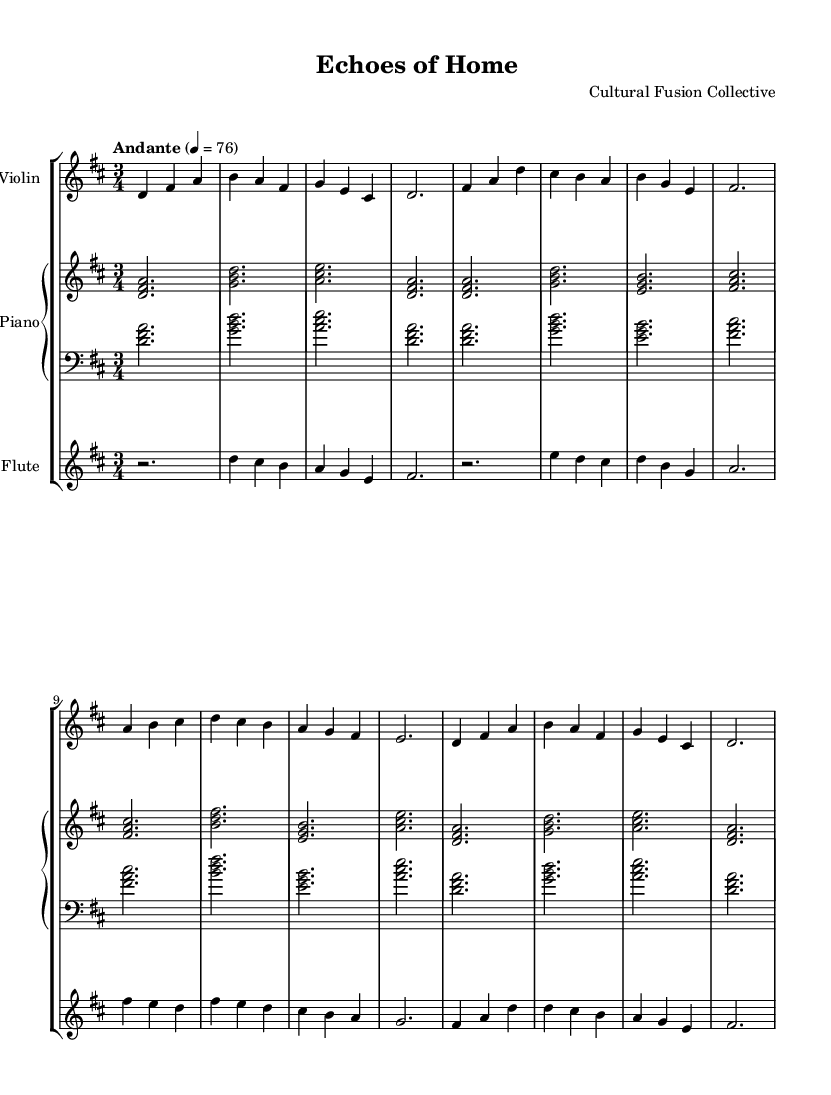What is the key signature of this music? The key signature is indicated at the beginning of the staff, showing two sharps, which indicates D major.
Answer: D major What is the time signature of the piece? The time signature is found as a fraction at the beginning of the sheet music, indicating that there are three beats in each measure, thus 3/4.
Answer: 3/4 What is the tempo marking for this music? The tempo marking "Andante" is stated at the beginning, specifying a moderate pace, and the metronome marking is provided as quarter note equals 76.
Answer: Andante How many measures are there in the violin part? Counting the number of measure bars in the violin part, there are a total of eight measures in the provided section of the music.
Answer: Eight Which instruments are featured in this score? The score includes three instruments, as indicated in the staff group header: Violin, Piano, and Flute.
Answer: Violin, Piano, Flute What is the harmonic structure of the first measure in the piano part? The first measure in the piano part features a D major chord, as shown by the notes played together: D, F sharp, and A.
Answer: D major chord What type of melody is showcased in this piece? This piece demonstrates a classical interpretation of folk melodies, highlighted in the title "Echoes of Home," suggesting a cultural fusion.
Answer: Folk melodies 